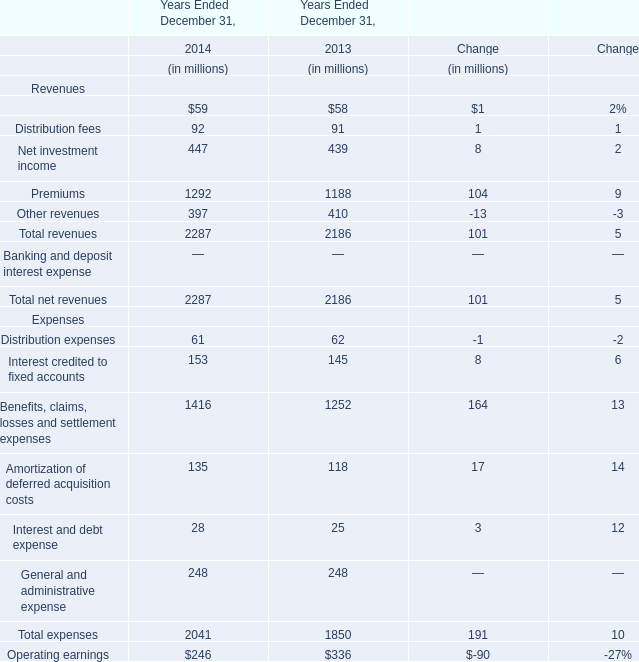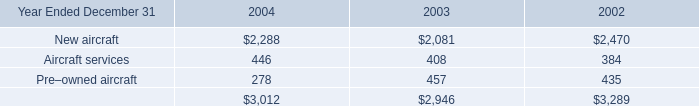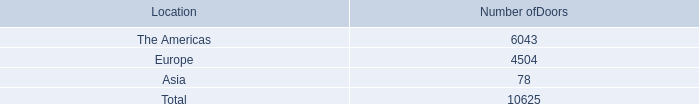What is the total amount of The Americas of Number ofDoors, and New aircraft of 2003 ? 
Computations: (6043.0 + 2081.0)
Answer: 8124.0. 